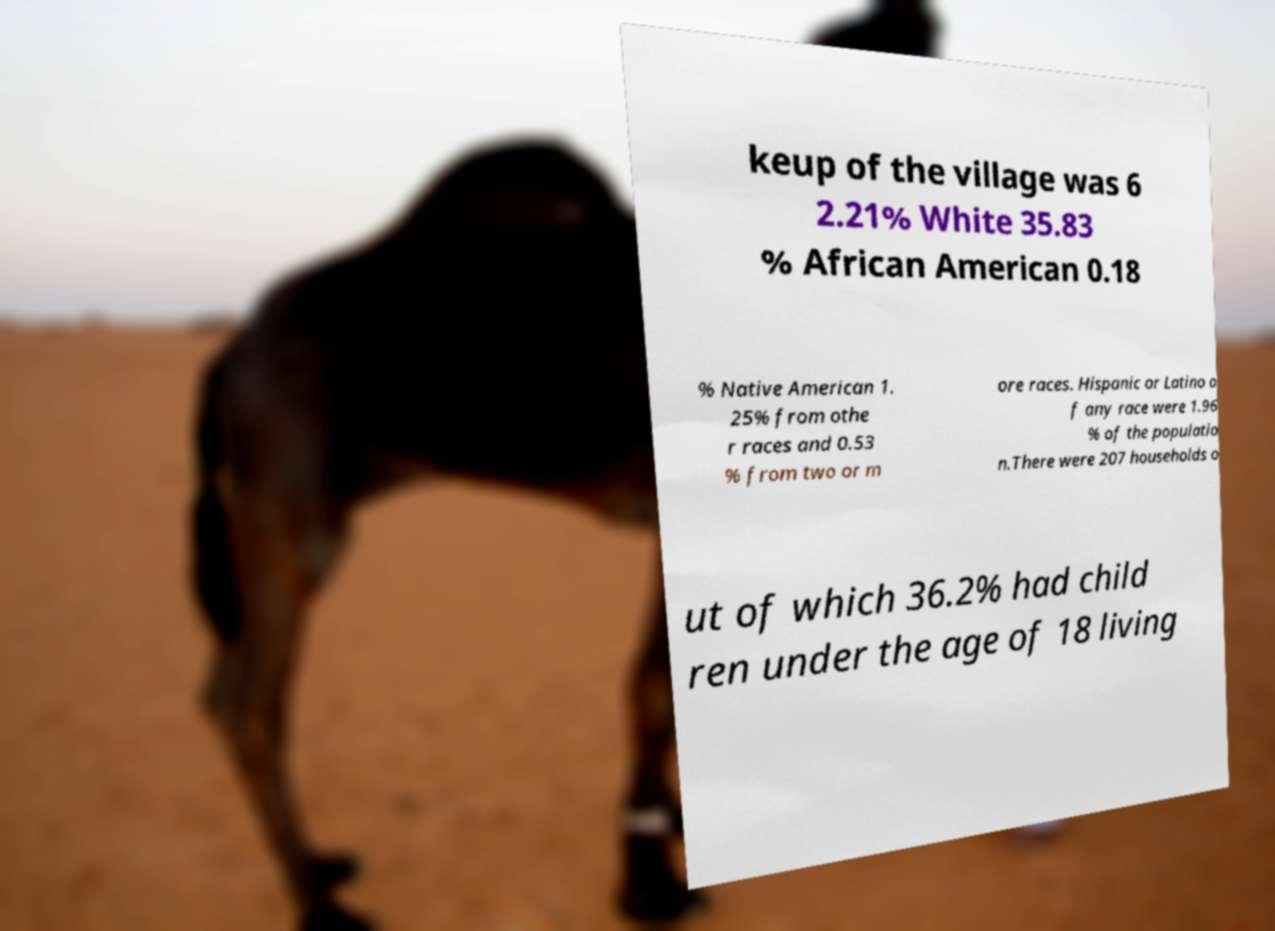Could you extract and type out the text from this image? keup of the village was 6 2.21% White 35.83 % African American 0.18 % Native American 1. 25% from othe r races and 0.53 % from two or m ore races. Hispanic or Latino o f any race were 1.96 % of the populatio n.There were 207 households o ut of which 36.2% had child ren under the age of 18 living 